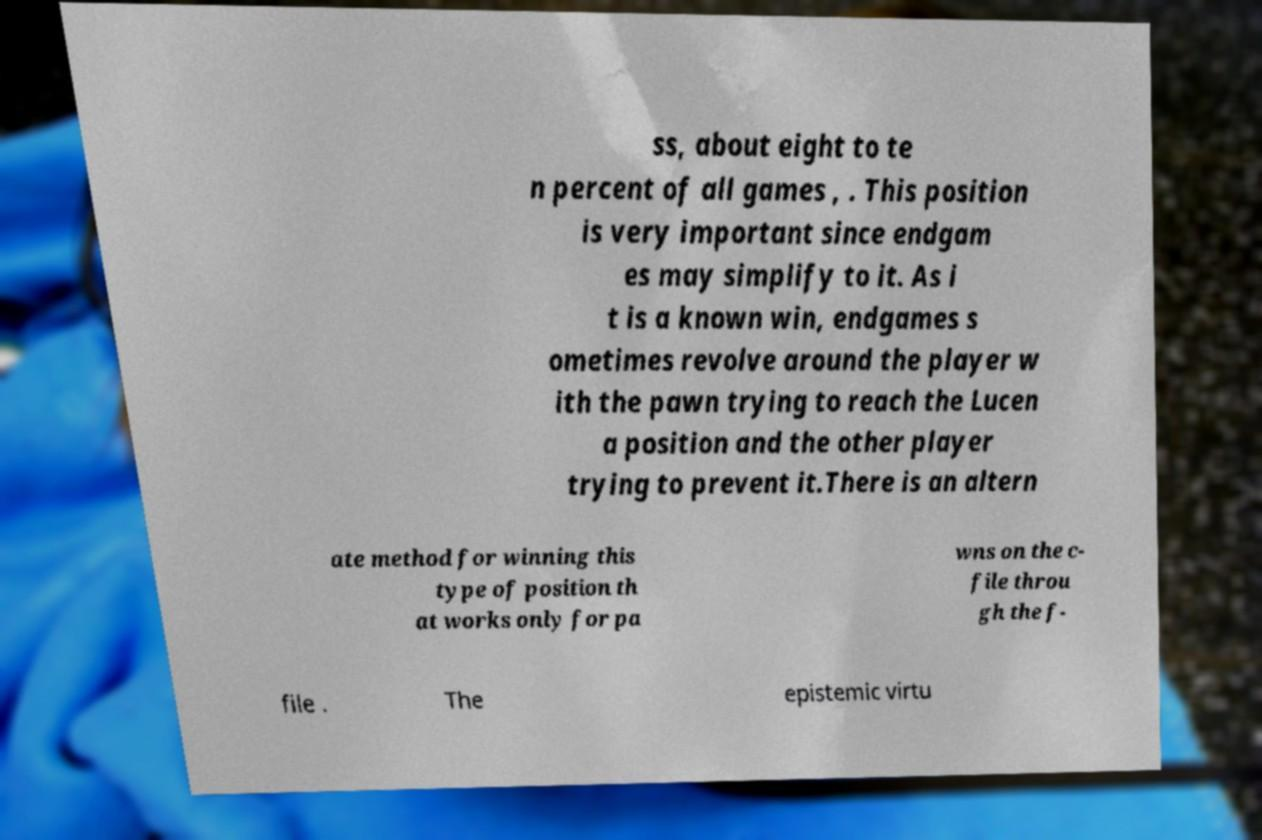Please identify and transcribe the text found in this image. ss, about eight to te n percent of all games , . This position is very important since endgam es may simplify to it. As i t is a known win, endgames s ometimes revolve around the player w ith the pawn trying to reach the Lucen a position and the other player trying to prevent it.There is an altern ate method for winning this type of position th at works only for pa wns on the c- file throu gh the f- file . The epistemic virtu 